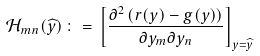Convert formula to latex. <formula><loc_0><loc_0><loc_500><loc_500>\mathcal { H } _ { m n } ( \widehat { y } ) \, \colon = \, \left [ \frac { \partial ^ { 2 } \left ( r ( y ) - g ( y ) \right ) } { \partial y _ { m } \partial y _ { n } } \right ] _ { y = \widehat { y } }</formula> 